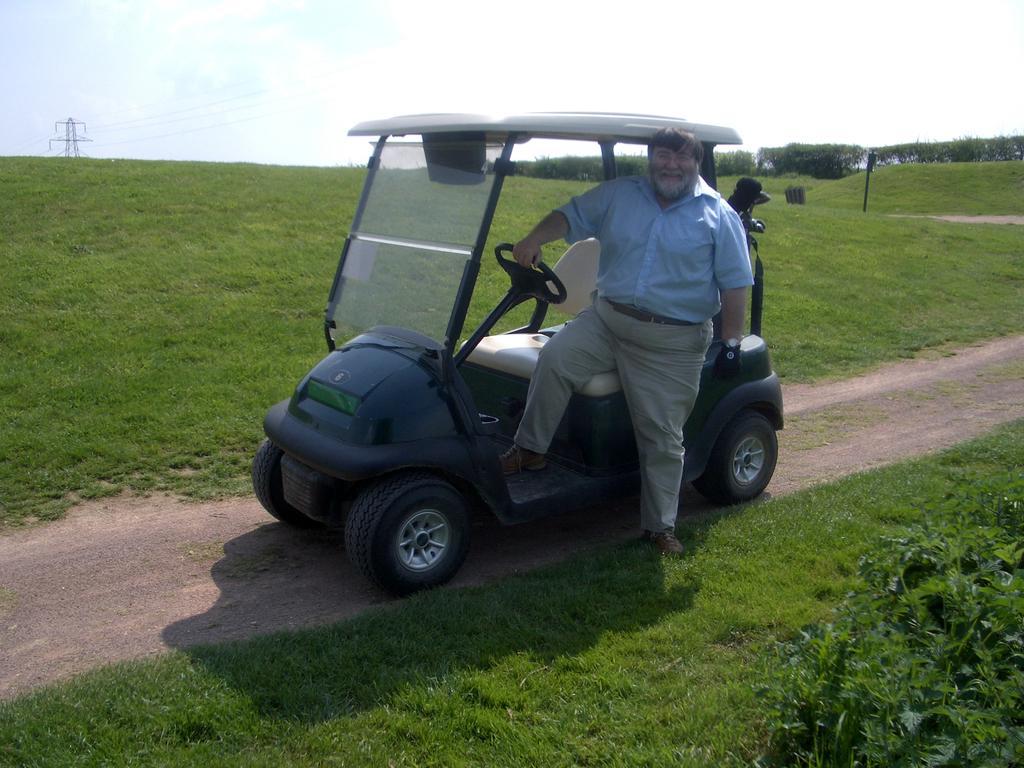In one or two sentences, can you explain what this image depicts? In this image we can see grass in the foreground and a man sitting in the vehicle. And on the back side also we can see the grass. The sky is clear. On the left top side we can see an electric pole and the top right side we can see the trees. 